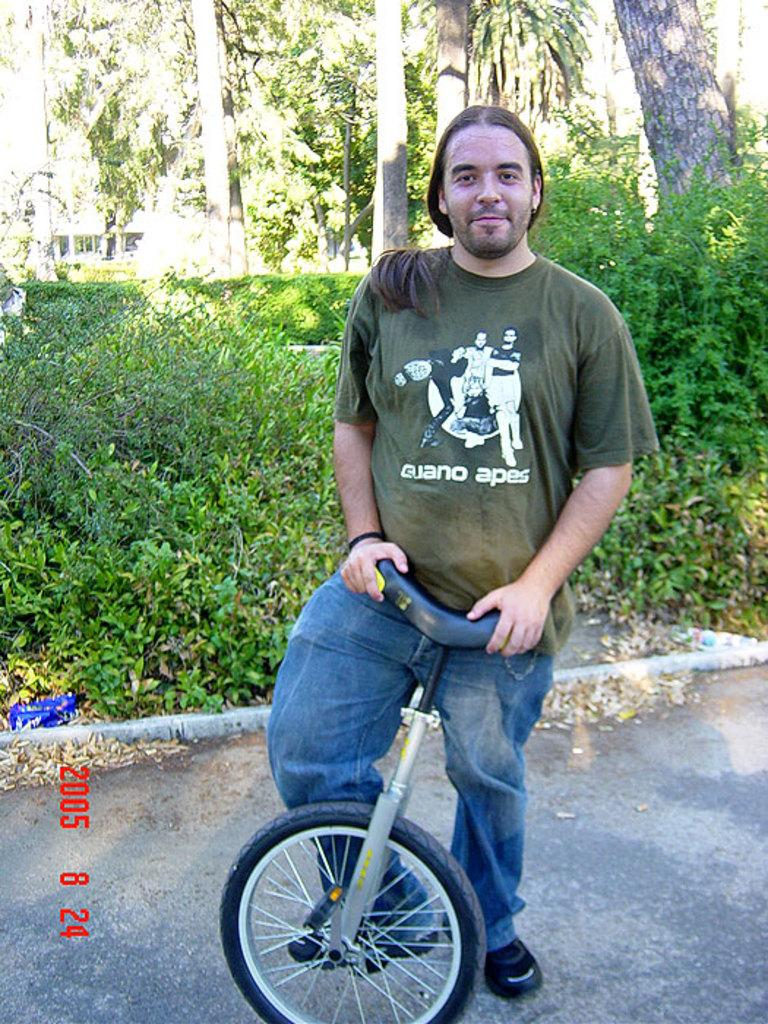What is the main subject of the image? The main subject of the image is a man. What is the man doing in the image? The man is standing by holding a cycle. What type of vegetation is present in the image? There are plants and trees in the image. What type of badge is the man wearing in the image? There is no badge visible on the man in the image. How many bits of information can be seen in the image? There is no reference to bits of information in the image. --- Facts: 1. There is a car in the image. 2. The car is parked on the side of the road. 3. There are streetlights in the image. 4. The sky is visible in the image. 5. There are buildings in the background of the image. Absurd Topics: parrot, sand, ocean Conversation: What is the main subject of the image? The main subject of the image is a car. Where is the car located in the image? The car is parked on the side of the road. What type of lighting is present in the image? There are streetlights in the image. What is visible in the background of the image? There are buildings in the background of the image. Reasoning: Let's think step by step in order to produce the conversation. We start by identifying the main subject of the image, which is the car. Then, we describe the location of the car, which is parked on the side of the road. Next, we mention the presence of streetlights in the image to provide a sense of the lighting conditions. Finally, we describe the background of the image, which includes buildings. Absurd Question/Answer: What type of parrot can be seen sitting on the car in the image? There is no parrot present on the car in the image. What type of sand can be seen on the beach in the image? There is no beach or sand present in the image. --- Facts: 1. There is a person in the image. 2. The person is holding a book. 3. There is a table in the image. 4. There is a chair in the image. 5. There is a lamp on the table in the image. Absurd Topics: elephant, volcano, rainbow Conversation: What is the main subject of the image? The main subject of the image is a person. What is the person holding in the image? The person is holding a book. What type of furniture is present in the image? There is a table and a chair in the image. What type of lighting is present on the table in the image? There is a lamp on the table in the image. Reasoning: Let's think step by step in order to produce the conversation. We start by identifying the main subject of the image, which is the person. Then 